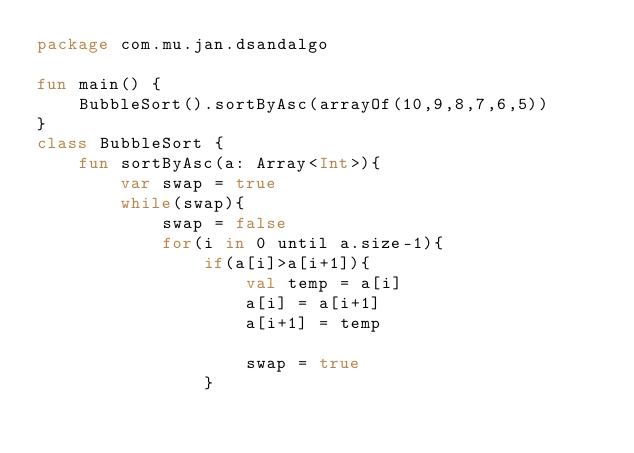<code> <loc_0><loc_0><loc_500><loc_500><_Kotlin_>package com.mu.jan.dsandalgo

fun main() {
    BubbleSort().sortByAsc(arrayOf(10,9,8,7,6,5))
}
class BubbleSort {
    fun sortByAsc(a: Array<Int>){
        var swap = true
        while(swap){
            swap = false
            for(i in 0 until a.size-1){
                if(a[i]>a[i+1]){
                    val temp = a[i]
                    a[i] = a[i+1]
                    a[i+1] = temp

                    swap = true
                }</code> 